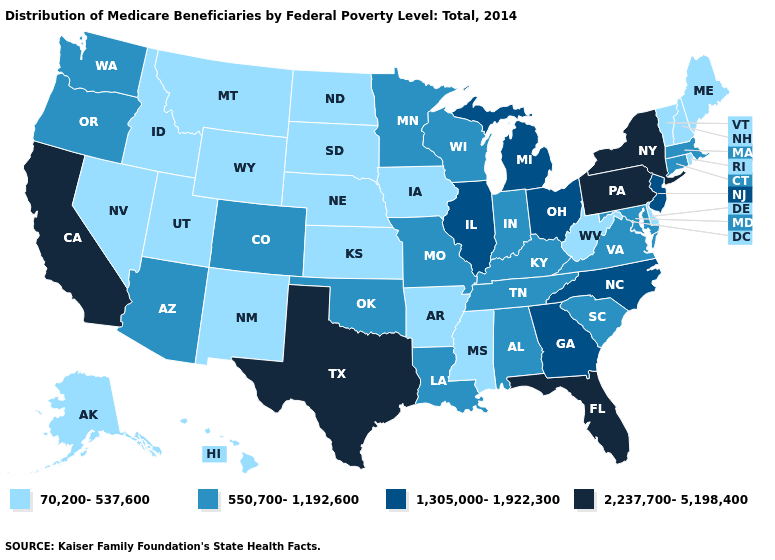What is the value of Utah?
Keep it brief. 70,200-537,600. Name the states that have a value in the range 1,305,000-1,922,300?
Give a very brief answer. Georgia, Illinois, Michigan, New Jersey, North Carolina, Ohio. Among the states that border Texas , does Louisiana have the lowest value?
Quick response, please. No. Name the states that have a value in the range 2,237,700-5,198,400?
Quick response, please. California, Florida, New York, Pennsylvania, Texas. What is the highest value in states that border Louisiana?
Write a very short answer. 2,237,700-5,198,400. Among the states that border Massachusetts , does Connecticut have the lowest value?
Give a very brief answer. No. Does South Dakota have the lowest value in the USA?
Answer briefly. Yes. Among the states that border Wyoming , does Idaho have the highest value?
Short answer required. No. Does Rhode Island have a higher value than Wyoming?
Write a very short answer. No. Among the states that border Washington , does Idaho have the lowest value?
Be succinct. Yes. What is the value of Nebraska?
Write a very short answer. 70,200-537,600. What is the lowest value in the South?
Keep it brief. 70,200-537,600. Among the states that border Maine , which have the highest value?
Be succinct. New Hampshire. Which states have the highest value in the USA?
Concise answer only. California, Florida, New York, Pennsylvania, Texas. Which states have the lowest value in the Northeast?
Concise answer only. Maine, New Hampshire, Rhode Island, Vermont. 